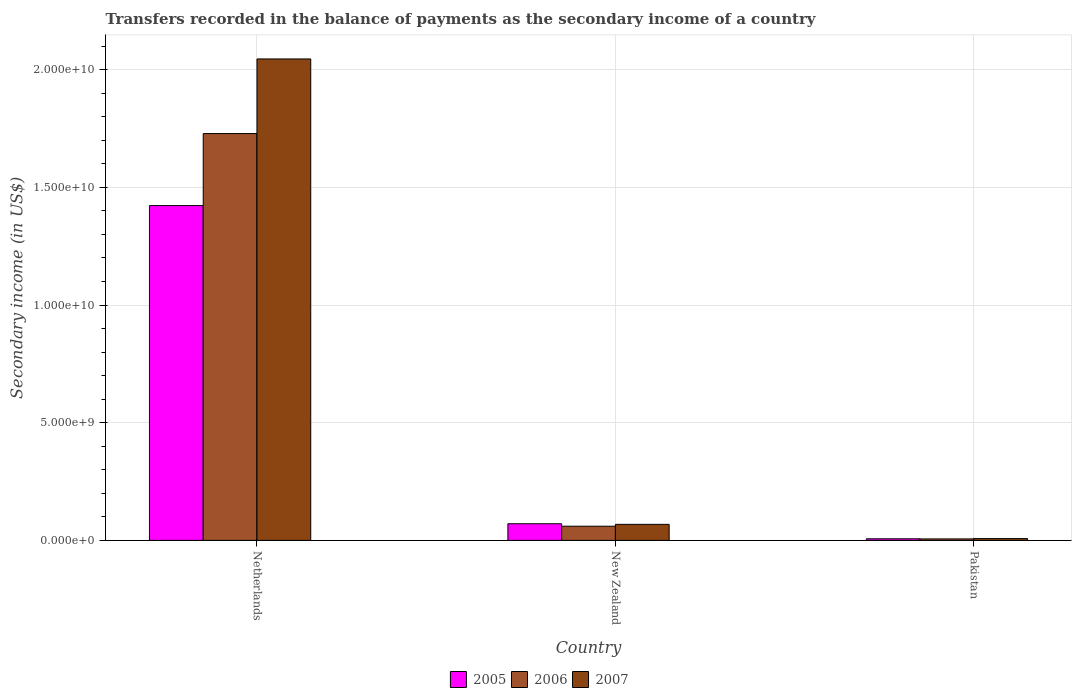How many different coloured bars are there?
Keep it short and to the point. 3. How many groups of bars are there?
Your answer should be very brief. 3. Are the number of bars on each tick of the X-axis equal?
Provide a short and direct response. Yes. How many bars are there on the 3rd tick from the left?
Provide a short and direct response. 3. How many bars are there on the 2nd tick from the right?
Your response must be concise. 3. What is the label of the 1st group of bars from the left?
Make the answer very short. Netherlands. What is the secondary income of in 2005 in New Zealand?
Your answer should be compact. 7.08e+08. Across all countries, what is the maximum secondary income of in 2005?
Provide a short and direct response. 1.42e+1. Across all countries, what is the minimum secondary income of in 2007?
Your response must be concise. 7.60e+07. In which country was the secondary income of in 2007 minimum?
Your response must be concise. Pakistan. What is the total secondary income of in 2005 in the graph?
Your answer should be compact. 1.50e+1. What is the difference between the secondary income of in 2005 in Netherlands and that in Pakistan?
Offer a terse response. 1.42e+1. What is the difference between the secondary income of in 2006 in New Zealand and the secondary income of in 2007 in Netherlands?
Provide a short and direct response. -1.99e+1. What is the average secondary income of in 2007 per country?
Offer a terse response. 7.07e+09. What is the difference between the secondary income of of/in 2005 and secondary income of of/in 2006 in New Zealand?
Your response must be concise. 1.05e+08. In how many countries, is the secondary income of in 2005 greater than 19000000000 US$?
Ensure brevity in your answer.  0. What is the ratio of the secondary income of in 2006 in New Zealand to that in Pakistan?
Your response must be concise. 9.56. Is the secondary income of in 2007 in New Zealand less than that in Pakistan?
Keep it short and to the point. No. What is the difference between the highest and the second highest secondary income of in 2007?
Give a very brief answer. 6.05e+08. What is the difference between the highest and the lowest secondary income of in 2005?
Keep it short and to the point. 1.42e+1. In how many countries, is the secondary income of in 2007 greater than the average secondary income of in 2007 taken over all countries?
Your answer should be very brief. 1. What does the 1st bar from the left in Netherlands represents?
Your answer should be compact. 2005. What does the 2nd bar from the right in Netherlands represents?
Ensure brevity in your answer.  2006. How many bars are there?
Your answer should be compact. 9. How many countries are there in the graph?
Offer a terse response. 3. Does the graph contain grids?
Offer a very short reply. Yes. Where does the legend appear in the graph?
Give a very brief answer. Bottom center. What is the title of the graph?
Ensure brevity in your answer.  Transfers recorded in the balance of payments as the secondary income of a country. What is the label or title of the Y-axis?
Offer a terse response. Secondary income (in US$). What is the Secondary income (in US$) of 2005 in Netherlands?
Ensure brevity in your answer.  1.42e+1. What is the Secondary income (in US$) of 2006 in Netherlands?
Ensure brevity in your answer.  1.73e+1. What is the Secondary income (in US$) in 2007 in Netherlands?
Provide a short and direct response. 2.05e+1. What is the Secondary income (in US$) in 2005 in New Zealand?
Provide a short and direct response. 7.08e+08. What is the Secondary income (in US$) in 2006 in New Zealand?
Your answer should be compact. 6.02e+08. What is the Secondary income (in US$) in 2007 in New Zealand?
Your answer should be very brief. 6.81e+08. What is the Secondary income (in US$) in 2005 in Pakistan?
Offer a terse response. 6.80e+07. What is the Secondary income (in US$) of 2006 in Pakistan?
Your answer should be compact. 6.30e+07. What is the Secondary income (in US$) of 2007 in Pakistan?
Make the answer very short. 7.60e+07. Across all countries, what is the maximum Secondary income (in US$) in 2005?
Your answer should be compact. 1.42e+1. Across all countries, what is the maximum Secondary income (in US$) of 2006?
Your answer should be very brief. 1.73e+1. Across all countries, what is the maximum Secondary income (in US$) of 2007?
Ensure brevity in your answer.  2.05e+1. Across all countries, what is the minimum Secondary income (in US$) in 2005?
Provide a succinct answer. 6.80e+07. Across all countries, what is the minimum Secondary income (in US$) of 2006?
Provide a succinct answer. 6.30e+07. Across all countries, what is the minimum Secondary income (in US$) of 2007?
Keep it short and to the point. 7.60e+07. What is the total Secondary income (in US$) of 2005 in the graph?
Provide a succinct answer. 1.50e+1. What is the total Secondary income (in US$) in 2006 in the graph?
Keep it short and to the point. 1.80e+1. What is the total Secondary income (in US$) in 2007 in the graph?
Make the answer very short. 2.12e+1. What is the difference between the Secondary income (in US$) in 2005 in Netherlands and that in New Zealand?
Your answer should be very brief. 1.35e+1. What is the difference between the Secondary income (in US$) in 2006 in Netherlands and that in New Zealand?
Provide a short and direct response. 1.67e+1. What is the difference between the Secondary income (in US$) of 2007 in Netherlands and that in New Zealand?
Provide a succinct answer. 1.98e+1. What is the difference between the Secondary income (in US$) of 2005 in Netherlands and that in Pakistan?
Offer a terse response. 1.42e+1. What is the difference between the Secondary income (in US$) of 2006 in Netherlands and that in Pakistan?
Your answer should be compact. 1.72e+1. What is the difference between the Secondary income (in US$) of 2007 in Netherlands and that in Pakistan?
Your response must be concise. 2.04e+1. What is the difference between the Secondary income (in US$) in 2005 in New Zealand and that in Pakistan?
Provide a short and direct response. 6.40e+08. What is the difference between the Secondary income (in US$) in 2006 in New Zealand and that in Pakistan?
Offer a terse response. 5.39e+08. What is the difference between the Secondary income (in US$) of 2007 in New Zealand and that in Pakistan?
Offer a terse response. 6.05e+08. What is the difference between the Secondary income (in US$) of 2005 in Netherlands and the Secondary income (in US$) of 2006 in New Zealand?
Your response must be concise. 1.36e+1. What is the difference between the Secondary income (in US$) in 2005 in Netherlands and the Secondary income (in US$) in 2007 in New Zealand?
Your answer should be very brief. 1.35e+1. What is the difference between the Secondary income (in US$) of 2006 in Netherlands and the Secondary income (in US$) of 2007 in New Zealand?
Give a very brief answer. 1.66e+1. What is the difference between the Secondary income (in US$) in 2005 in Netherlands and the Secondary income (in US$) in 2006 in Pakistan?
Offer a terse response. 1.42e+1. What is the difference between the Secondary income (in US$) of 2005 in Netherlands and the Secondary income (in US$) of 2007 in Pakistan?
Offer a terse response. 1.42e+1. What is the difference between the Secondary income (in US$) of 2006 in Netherlands and the Secondary income (in US$) of 2007 in Pakistan?
Your answer should be very brief. 1.72e+1. What is the difference between the Secondary income (in US$) of 2005 in New Zealand and the Secondary income (in US$) of 2006 in Pakistan?
Offer a terse response. 6.45e+08. What is the difference between the Secondary income (in US$) of 2005 in New Zealand and the Secondary income (in US$) of 2007 in Pakistan?
Offer a very short reply. 6.32e+08. What is the difference between the Secondary income (in US$) in 2006 in New Zealand and the Secondary income (in US$) in 2007 in Pakistan?
Your answer should be very brief. 5.26e+08. What is the average Secondary income (in US$) of 2005 per country?
Your answer should be compact. 5.00e+09. What is the average Secondary income (in US$) of 2006 per country?
Your response must be concise. 5.98e+09. What is the average Secondary income (in US$) in 2007 per country?
Provide a short and direct response. 7.07e+09. What is the difference between the Secondary income (in US$) in 2005 and Secondary income (in US$) in 2006 in Netherlands?
Provide a short and direct response. -3.06e+09. What is the difference between the Secondary income (in US$) in 2005 and Secondary income (in US$) in 2007 in Netherlands?
Offer a very short reply. -6.23e+09. What is the difference between the Secondary income (in US$) in 2006 and Secondary income (in US$) in 2007 in Netherlands?
Make the answer very short. -3.17e+09. What is the difference between the Secondary income (in US$) in 2005 and Secondary income (in US$) in 2006 in New Zealand?
Provide a succinct answer. 1.05e+08. What is the difference between the Secondary income (in US$) of 2005 and Secondary income (in US$) of 2007 in New Zealand?
Provide a short and direct response. 2.63e+07. What is the difference between the Secondary income (in US$) in 2006 and Secondary income (in US$) in 2007 in New Zealand?
Make the answer very short. -7.89e+07. What is the difference between the Secondary income (in US$) of 2005 and Secondary income (in US$) of 2006 in Pakistan?
Provide a succinct answer. 5.00e+06. What is the difference between the Secondary income (in US$) of 2005 and Secondary income (in US$) of 2007 in Pakistan?
Your answer should be compact. -8.00e+06. What is the difference between the Secondary income (in US$) of 2006 and Secondary income (in US$) of 2007 in Pakistan?
Make the answer very short. -1.30e+07. What is the ratio of the Secondary income (in US$) of 2005 in Netherlands to that in New Zealand?
Offer a terse response. 20.11. What is the ratio of the Secondary income (in US$) in 2006 in Netherlands to that in New Zealand?
Keep it short and to the point. 28.7. What is the ratio of the Secondary income (in US$) in 2007 in Netherlands to that in New Zealand?
Ensure brevity in your answer.  30.03. What is the ratio of the Secondary income (in US$) of 2005 in Netherlands to that in Pakistan?
Your answer should be compact. 209.21. What is the ratio of the Secondary income (in US$) of 2006 in Netherlands to that in Pakistan?
Give a very brief answer. 274.4. What is the ratio of the Secondary income (in US$) in 2007 in Netherlands to that in Pakistan?
Your response must be concise. 269.18. What is the ratio of the Secondary income (in US$) of 2005 in New Zealand to that in Pakistan?
Offer a very short reply. 10.4. What is the ratio of the Secondary income (in US$) in 2006 in New Zealand to that in Pakistan?
Offer a terse response. 9.56. What is the ratio of the Secondary income (in US$) in 2007 in New Zealand to that in Pakistan?
Keep it short and to the point. 8.96. What is the difference between the highest and the second highest Secondary income (in US$) in 2005?
Provide a short and direct response. 1.35e+1. What is the difference between the highest and the second highest Secondary income (in US$) of 2006?
Ensure brevity in your answer.  1.67e+1. What is the difference between the highest and the second highest Secondary income (in US$) in 2007?
Your answer should be compact. 1.98e+1. What is the difference between the highest and the lowest Secondary income (in US$) of 2005?
Make the answer very short. 1.42e+1. What is the difference between the highest and the lowest Secondary income (in US$) in 2006?
Offer a very short reply. 1.72e+1. What is the difference between the highest and the lowest Secondary income (in US$) in 2007?
Offer a terse response. 2.04e+1. 